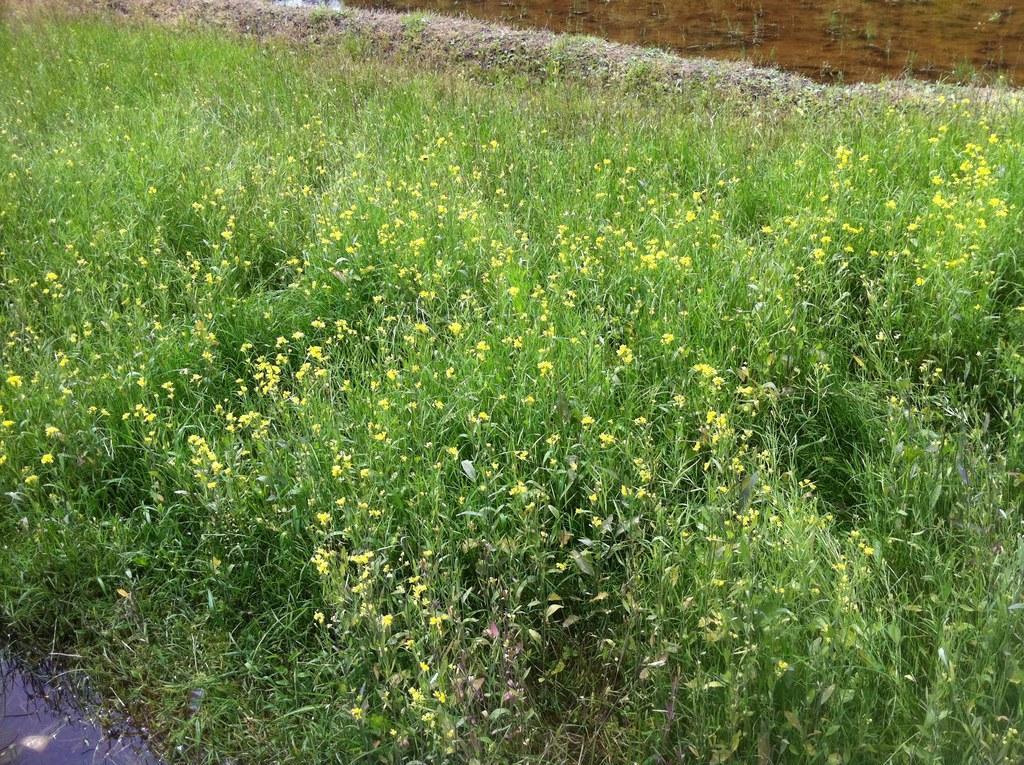Describe this image in one or two sentences. In the image we can see some flowers and grass and water. 